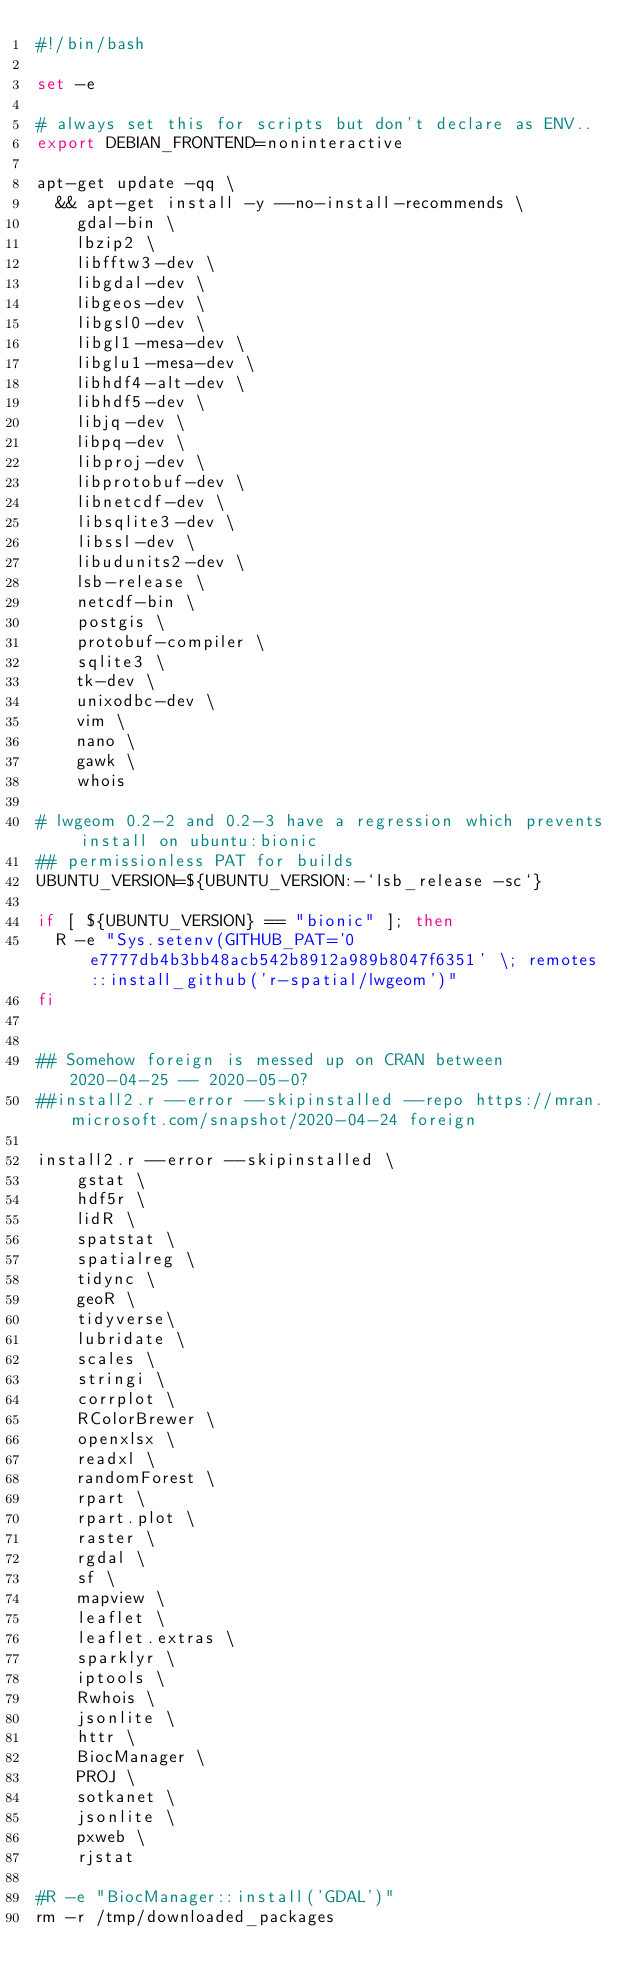Convert code to text. <code><loc_0><loc_0><loc_500><loc_500><_Bash_>#!/bin/bash

set -e

# always set this for scripts but don't declare as ENV..
export DEBIAN_FRONTEND=noninteractive

apt-get update -qq \
  && apt-get install -y --no-install-recommends \
    gdal-bin \
    lbzip2 \
    libfftw3-dev \
    libgdal-dev \
    libgeos-dev \
    libgsl0-dev \
    libgl1-mesa-dev \
    libglu1-mesa-dev \
    libhdf4-alt-dev \
    libhdf5-dev \
    libjq-dev \
    libpq-dev \
    libproj-dev \
    libprotobuf-dev \
    libnetcdf-dev \
    libsqlite3-dev \
    libssl-dev \
    libudunits2-dev \
    lsb-release \
    netcdf-bin \
    postgis \
    protobuf-compiler \
    sqlite3 \
    tk-dev \
    unixodbc-dev \
    vim \
    nano \
    gawk \
    whois 

# lwgeom 0.2-2 and 0.2-3 have a regression which prevents install on ubuntu:bionic
## permissionless PAT for builds
UBUNTU_VERSION=${UBUNTU_VERSION:-`lsb_release -sc`}

if [ ${UBUNTU_VERSION} == "bionic" ]; then 
  R -e "Sys.setenv(GITHUB_PAT='0e7777db4b3bb48acb542b8912a989b8047f6351' \; remotes::install_github('r-spatial/lwgeom')"
fi


## Somehow foreign is messed up on CRAN between 2020-04-25 -- 2020-05-0?  
##install2.r --error --skipinstalled --repo https://mran.microsoft.com/snapshot/2020-04-24 foreign

install2.r --error --skipinstalled \
    gstat \
    hdf5r \
    lidR \
    spatstat \
    spatialreg \
    tidync \
    geoR \
    tidyverse\
    lubridate \
    scales \
    stringi \
    corrplot \
    RColorBrewer \
    openxlsx \
    readxl \
    randomForest \
    rpart \
    rpart.plot \
    raster \
    rgdal \
    sf \
    mapview \
    leaflet \
    leaflet.extras \
    sparklyr \
    iptools \
    Rwhois \
    jsonlite \
    httr \
    BiocManager \
    PROJ \
    sotkanet \
    jsonlite \
    pxweb \
    rjstat

#R -e "BiocManager::install('GDAL')"
rm -r /tmp/downloaded_packages
</code> 